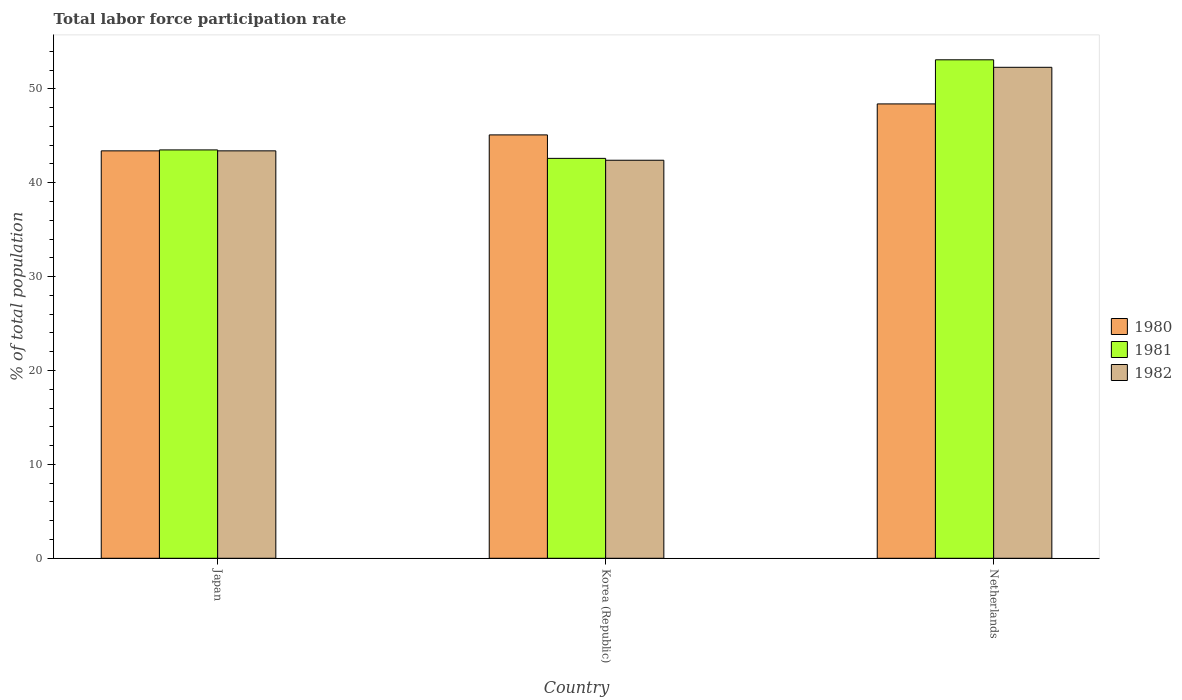Are the number of bars on each tick of the X-axis equal?
Your answer should be compact. Yes. What is the total labor force participation rate in 1981 in Korea (Republic)?
Offer a very short reply. 42.6. Across all countries, what is the maximum total labor force participation rate in 1980?
Your answer should be very brief. 48.4. Across all countries, what is the minimum total labor force participation rate in 1982?
Give a very brief answer. 42.4. In which country was the total labor force participation rate in 1982 maximum?
Offer a very short reply. Netherlands. What is the total total labor force participation rate in 1980 in the graph?
Give a very brief answer. 136.9. What is the difference between the total labor force participation rate in 1980 in Korea (Republic) and that in Netherlands?
Ensure brevity in your answer.  -3.3. What is the difference between the total labor force participation rate in 1981 in Netherlands and the total labor force participation rate in 1980 in Korea (Republic)?
Ensure brevity in your answer.  8. What is the average total labor force participation rate in 1982 per country?
Your answer should be compact. 46.03. What is the difference between the total labor force participation rate of/in 1982 and total labor force participation rate of/in 1981 in Korea (Republic)?
Make the answer very short. -0.2. In how many countries, is the total labor force participation rate in 1980 greater than 2 %?
Ensure brevity in your answer.  3. What is the ratio of the total labor force participation rate in 1980 in Japan to that in Netherlands?
Make the answer very short. 0.9. What is the difference between the highest and the second highest total labor force participation rate in 1982?
Give a very brief answer. -1. Is the sum of the total labor force participation rate in 1980 in Japan and Netherlands greater than the maximum total labor force participation rate in 1982 across all countries?
Your answer should be very brief. Yes. How many bars are there?
Your answer should be very brief. 9. How many countries are there in the graph?
Offer a very short reply. 3. What is the difference between two consecutive major ticks on the Y-axis?
Your answer should be compact. 10. Does the graph contain any zero values?
Your response must be concise. No. How are the legend labels stacked?
Offer a very short reply. Vertical. What is the title of the graph?
Provide a succinct answer. Total labor force participation rate. Does "1968" appear as one of the legend labels in the graph?
Make the answer very short. No. What is the label or title of the Y-axis?
Offer a terse response. % of total population. What is the % of total population in 1980 in Japan?
Ensure brevity in your answer.  43.4. What is the % of total population in 1981 in Japan?
Keep it short and to the point. 43.5. What is the % of total population of 1982 in Japan?
Your answer should be very brief. 43.4. What is the % of total population of 1980 in Korea (Republic)?
Keep it short and to the point. 45.1. What is the % of total population of 1981 in Korea (Republic)?
Provide a short and direct response. 42.6. What is the % of total population of 1982 in Korea (Republic)?
Offer a terse response. 42.4. What is the % of total population of 1980 in Netherlands?
Provide a short and direct response. 48.4. What is the % of total population in 1981 in Netherlands?
Give a very brief answer. 53.1. What is the % of total population of 1982 in Netherlands?
Make the answer very short. 52.3. Across all countries, what is the maximum % of total population of 1980?
Your response must be concise. 48.4. Across all countries, what is the maximum % of total population of 1981?
Provide a succinct answer. 53.1. Across all countries, what is the maximum % of total population in 1982?
Provide a short and direct response. 52.3. Across all countries, what is the minimum % of total population in 1980?
Your answer should be very brief. 43.4. Across all countries, what is the minimum % of total population of 1981?
Provide a succinct answer. 42.6. Across all countries, what is the minimum % of total population in 1982?
Your response must be concise. 42.4. What is the total % of total population in 1980 in the graph?
Give a very brief answer. 136.9. What is the total % of total population of 1981 in the graph?
Your answer should be compact. 139.2. What is the total % of total population of 1982 in the graph?
Your answer should be compact. 138.1. What is the difference between the % of total population in 1980 in Japan and that in Korea (Republic)?
Make the answer very short. -1.7. What is the difference between the % of total population in 1982 in Korea (Republic) and that in Netherlands?
Your answer should be compact. -9.9. What is the difference between the % of total population of 1980 in Japan and the % of total population of 1982 in Korea (Republic)?
Offer a terse response. 1. What is the difference between the % of total population in 1981 in Japan and the % of total population in 1982 in Korea (Republic)?
Give a very brief answer. 1.1. What is the difference between the % of total population of 1980 in Japan and the % of total population of 1982 in Netherlands?
Keep it short and to the point. -8.9. What is the difference between the % of total population of 1980 in Korea (Republic) and the % of total population of 1982 in Netherlands?
Provide a succinct answer. -7.2. What is the average % of total population in 1980 per country?
Your answer should be compact. 45.63. What is the average % of total population of 1981 per country?
Your response must be concise. 46.4. What is the average % of total population of 1982 per country?
Offer a terse response. 46.03. What is the difference between the % of total population of 1980 and % of total population of 1981 in Japan?
Your answer should be compact. -0.1. What is the difference between the % of total population in 1980 and % of total population in 1982 in Japan?
Your answer should be compact. 0. What is the difference between the % of total population in 1980 and % of total population in 1981 in Netherlands?
Offer a terse response. -4.7. What is the difference between the % of total population in 1980 and % of total population in 1982 in Netherlands?
Your answer should be very brief. -3.9. What is the ratio of the % of total population in 1980 in Japan to that in Korea (Republic)?
Give a very brief answer. 0.96. What is the ratio of the % of total population in 1981 in Japan to that in Korea (Republic)?
Offer a very short reply. 1.02. What is the ratio of the % of total population in 1982 in Japan to that in Korea (Republic)?
Give a very brief answer. 1.02. What is the ratio of the % of total population in 1980 in Japan to that in Netherlands?
Make the answer very short. 0.9. What is the ratio of the % of total population of 1981 in Japan to that in Netherlands?
Offer a very short reply. 0.82. What is the ratio of the % of total population of 1982 in Japan to that in Netherlands?
Your response must be concise. 0.83. What is the ratio of the % of total population of 1980 in Korea (Republic) to that in Netherlands?
Provide a short and direct response. 0.93. What is the ratio of the % of total population of 1981 in Korea (Republic) to that in Netherlands?
Give a very brief answer. 0.8. What is the ratio of the % of total population in 1982 in Korea (Republic) to that in Netherlands?
Your answer should be compact. 0.81. What is the difference between the highest and the second highest % of total population in 1981?
Provide a succinct answer. 9.6. What is the difference between the highest and the lowest % of total population in 1981?
Provide a short and direct response. 10.5. What is the difference between the highest and the lowest % of total population of 1982?
Your answer should be compact. 9.9. 